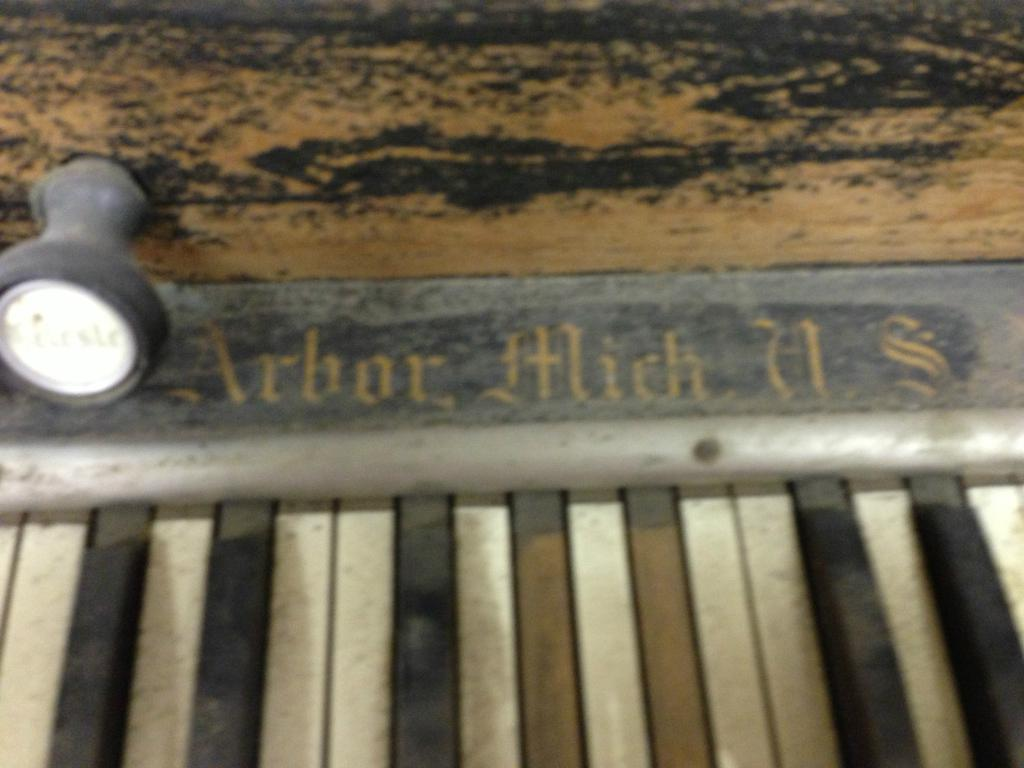What musical instrument is present in the image? There is a piano in the image. What else can be seen in the image besides the piano? There is text and a button in the image. How many cats are sitting on the piano in the image? There are no cats present in the image; it only features a piano, text, and a button. 